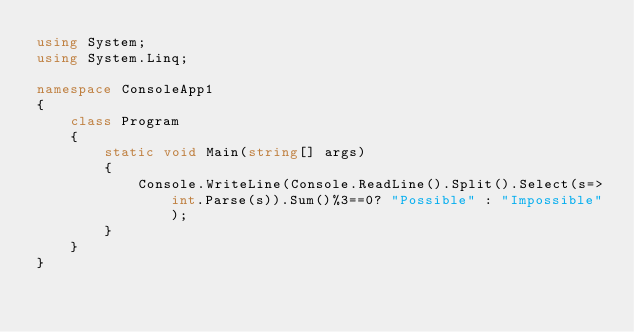Convert code to text. <code><loc_0><loc_0><loc_500><loc_500><_C#_>using System;
using System.Linq;

namespace ConsoleApp1
{
    class Program
    {
        static void Main(string[] args)
        {
            Console.WriteLine(Console.ReadLine().Split().Select(s=>int.Parse(s)).Sum()%3==0? "Possible" : "Impossible");
        }
    }
}
</code> 